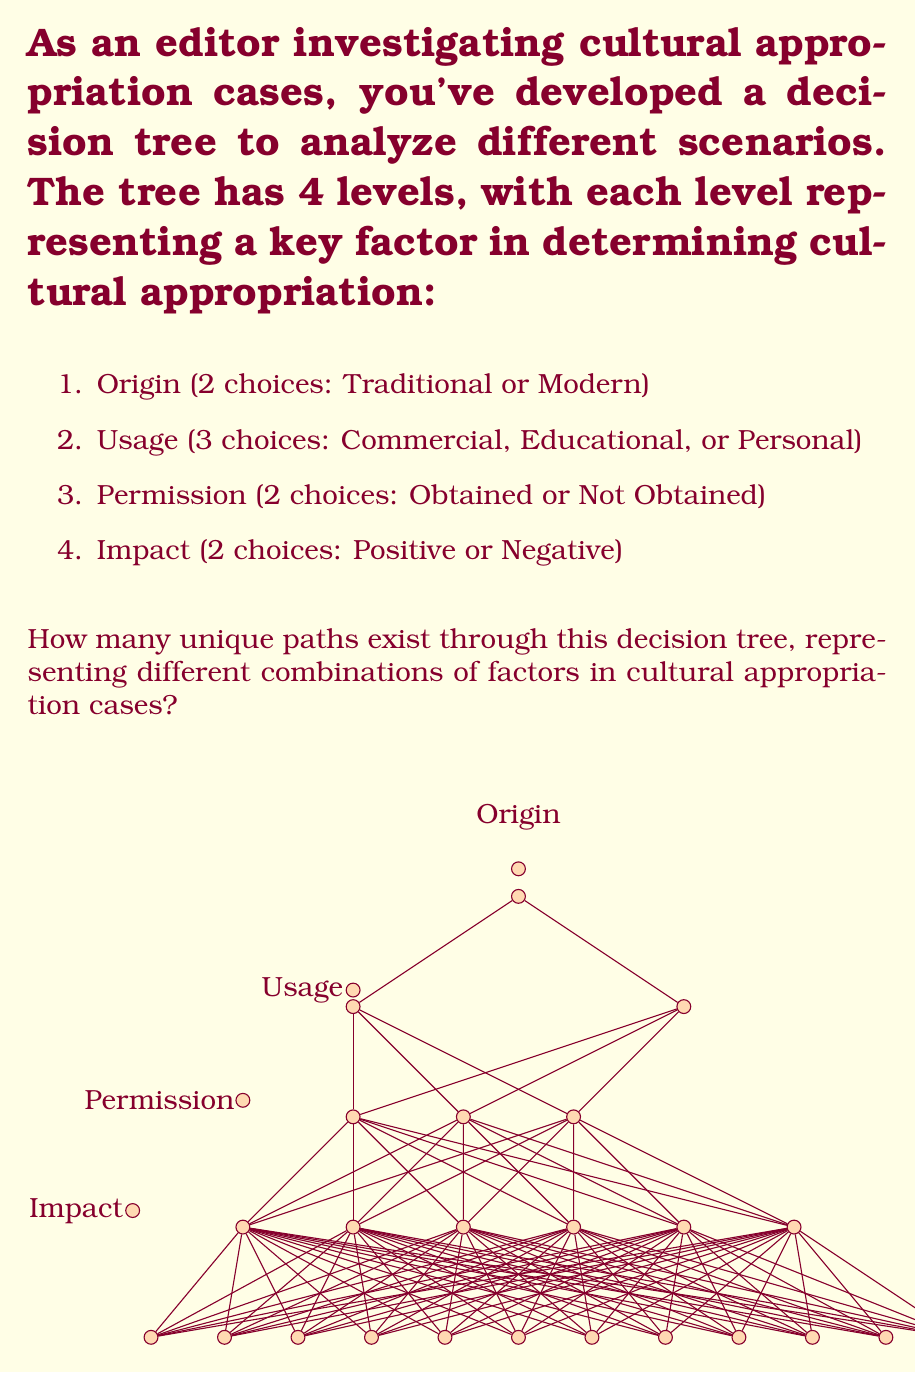Show me your answer to this math problem. To solve this problem, we'll use the multiplication principle of combinatorics. We'll multiply the number of choices at each level to get the total number of unique paths.

1. First level (Origin): 2 choices
2. Second level (Usage): 3 choices
3. Third level (Permission): 2 choices
4. Fourth level (Impact): 2 choices

The total number of unique paths is the product of these choices:

$$ \text{Total paths} = 2 \times 3 \times 2 \times 2 $$

Let's calculate:

$$ \begin{align*}
\text{Total paths} &= 2 \times 3 \times 2 \times 2 \\
&= 6 \times 4 \\
&= 24
\end{align*} $$

Therefore, there are 24 unique paths through this decision tree, each representing a different combination of factors in cultural appropriation cases.
Answer: 24 